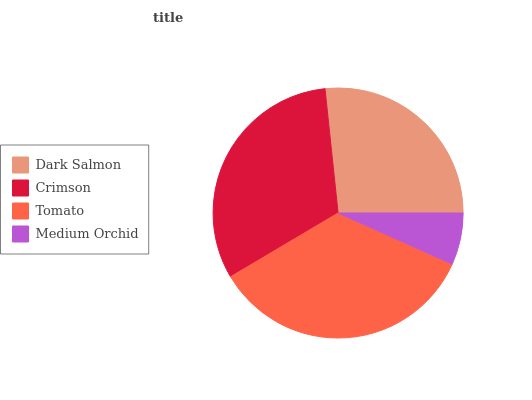Is Medium Orchid the minimum?
Answer yes or no. Yes. Is Tomato the maximum?
Answer yes or no. Yes. Is Crimson the minimum?
Answer yes or no. No. Is Crimson the maximum?
Answer yes or no. No. Is Crimson greater than Dark Salmon?
Answer yes or no. Yes. Is Dark Salmon less than Crimson?
Answer yes or no. Yes. Is Dark Salmon greater than Crimson?
Answer yes or no. No. Is Crimson less than Dark Salmon?
Answer yes or no. No. Is Crimson the high median?
Answer yes or no. Yes. Is Dark Salmon the low median?
Answer yes or no. Yes. Is Tomato the high median?
Answer yes or no. No. Is Crimson the low median?
Answer yes or no. No. 